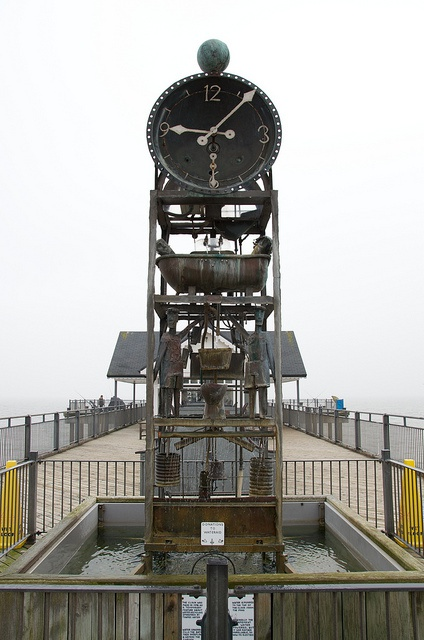Describe the objects in this image and their specific colors. I can see clock in white, black, gray, and darkgray tones and people in white, gray, darkgray, and black tones in this image. 